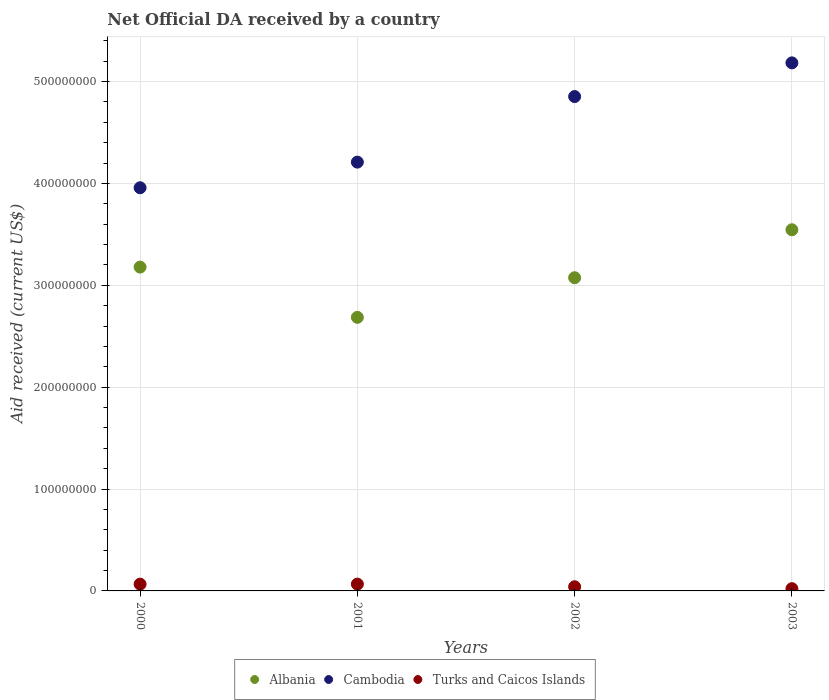How many different coloured dotlines are there?
Make the answer very short. 3. What is the net official development assistance aid received in Turks and Caicos Islands in 2000?
Ensure brevity in your answer.  6.65e+06. Across all years, what is the maximum net official development assistance aid received in Turks and Caicos Islands?
Keep it short and to the point. 6.67e+06. Across all years, what is the minimum net official development assistance aid received in Albania?
Offer a very short reply. 2.69e+08. In which year was the net official development assistance aid received in Cambodia minimum?
Keep it short and to the point. 2000. What is the total net official development assistance aid received in Cambodia in the graph?
Ensure brevity in your answer.  1.82e+09. What is the difference between the net official development assistance aid received in Cambodia in 2000 and that in 2003?
Provide a short and direct response. -1.23e+08. What is the difference between the net official development assistance aid received in Turks and Caicos Islands in 2003 and the net official development assistance aid received in Cambodia in 2001?
Your answer should be compact. -4.19e+08. What is the average net official development assistance aid received in Turks and Caicos Islands per year?
Your answer should be very brief. 4.90e+06. In the year 2001, what is the difference between the net official development assistance aid received in Albania and net official development assistance aid received in Cambodia?
Give a very brief answer. -1.52e+08. In how many years, is the net official development assistance aid received in Turks and Caicos Islands greater than 380000000 US$?
Your answer should be compact. 0. What is the ratio of the net official development assistance aid received in Cambodia in 2001 to that in 2002?
Make the answer very short. 0.87. Is the net official development assistance aid received in Albania in 2000 less than that in 2003?
Offer a terse response. Yes. Is the difference between the net official development assistance aid received in Albania in 2002 and 2003 greater than the difference between the net official development assistance aid received in Cambodia in 2002 and 2003?
Provide a short and direct response. No. What is the difference between the highest and the second highest net official development assistance aid received in Cambodia?
Keep it short and to the point. 3.31e+07. What is the difference between the highest and the lowest net official development assistance aid received in Albania?
Offer a terse response. 8.60e+07. Is it the case that in every year, the sum of the net official development assistance aid received in Turks and Caicos Islands and net official development assistance aid received in Cambodia  is greater than the net official development assistance aid received in Albania?
Provide a succinct answer. Yes. Does the net official development assistance aid received in Albania monotonically increase over the years?
Offer a terse response. No. Is the net official development assistance aid received in Albania strictly greater than the net official development assistance aid received in Turks and Caicos Islands over the years?
Your answer should be compact. Yes. How many dotlines are there?
Your answer should be very brief. 3. How many years are there in the graph?
Provide a succinct answer. 4. Does the graph contain any zero values?
Keep it short and to the point. No. Does the graph contain grids?
Make the answer very short. Yes. How are the legend labels stacked?
Your answer should be very brief. Horizontal. What is the title of the graph?
Make the answer very short. Net Official DA received by a country. Does "Sint Maarten (Dutch part)" appear as one of the legend labels in the graph?
Ensure brevity in your answer.  No. What is the label or title of the X-axis?
Provide a succinct answer. Years. What is the label or title of the Y-axis?
Keep it short and to the point. Aid received (current US$). What is the Aid received (current US$) in Albania in 2000?
Give a very brief answer. 3.18e+08. What is the Aid received (current US$) in Cambodia in 2000?
Provide a succinct answer. 3.96e+08. What is the Aid received (current US$) in Turks and Caicos Islands in 2000?
Ensure brevity in your answer.  6.65e+06. What is the Aid received (current US$) in Albania in 2001?
Provide a short and direct response. 2.69e+08. What is the Aid received (current US$) in Cambodia in 2001?
Your response must be concise. 4.21e+08. What is the Aid received (current US$) in Turks and Caicos Islands in 2001?
Offer a very short reply. 6.67e+06. What is the Aid received (current US$) of Albania in 2002?
Provide a succinct answer. 3.07e+08. What is the Aid received (current US$) of Cambodia in 2002?
Offer a terse response. 4.85e+08. What is the Aid received (current US$) of Turks and Caicos Islands in 2002?
Offer a terse response. 4.10e+06. What is the Aid received (current US$) in Albania in 2003?
Make the answer very short. 3.54e+08. What is the Aid received (current US$) of Cambodia in 2003?
Your answer should be very brief. 5.18e+08. What is the Aid received (current US$) of Turks and Caicos Islands in 2003?
Your answer should be compact. 2.20e+06. Across all years, what is the maximum Aid received (current US$) of Albania?
Ensure brevity in your answer.  3.54e+08. Across all years, what is the maximum Aid received (current US$) in Cambodia?
Ensure brevity in your answer.  5.18e+08. Across all years, what is the maximum Aid received (current US$) in Turks and Caicos Islands?
Offer a very short reply. 6.67e+06. Across all years, what is the minimum Aid received (current US$) of Albania?
Provide a short and direct response. 2.69e+08. Across all years, what is the minimum Aid received (current US$) in Cambodia?
Provide a short and direct response. 3.96e+08. Across all years, what is the minimum Aid received (current US$) of Turks and Caicos Islands?
Your answer should be very brief. 2.20e+06. What is the total Aid received (current US$) of Albania in the graph?
Your response must be concise. 1.25e+09. What is the total Aid received (current US$) in Cambodia in the graph?
Offer a terse response. 1.82e+09. What is the total Aid received (current US$) in Turks and Caicos Islands in the graph?
Your answer should be compact. 1.96e+07. What is the difference between the Aid received (current US$) of Albania in 2000 and that in 2001?
Your answer should be very brief. 4.93e+07. What is the difference between the Aid received (current US$) in Cambodia in 2000 and that in 2001?
Ensure brevity in your answer.  -2.52e+07. What is the difference between the Aid received (current US$) of Turks and Caicos Islands in 2000 and that in 2001?
Your answer should be very brief. -2.00e+04. What is the difference between the Aid received (current US$) in Albania in 2000 and that in 2002?
Your answer should be very brief. 1.04e+07. What is the difference between the Aid received (current US$) of Cambodia in 2000 and that in 2002?
Keep it short and to the point. -8.95e+07. What is the difference between the Aid received (current US$) of Turks and Caicos Islands in 2000 and that in 2002?
Provide a short and direct response. 2.55e+06. What is the difference between the Aid received (current US$) in Albania in 2000 and that in 2003?
Your response must be concise. -3.66e+07. What is the difference between the Aid received (current US$) of Cambodia in 2000 and that in 2003?
Offer a very short reply. -1.23e+08. What is the difference between the Aid received (current US$) of Turks and Caicos Islands in 2000 and that in 2003?
Ensure brevity in your answer.  4.45e+06. What is the difference between the Aid received (current US$) in Albania in 2001 and that in 2002?
Make the answer very short. -3.89e+07. What is the difference between the Aid received (current US$) in Cambodia in 2001 and that in 2002?
Offer a terse response. -6.44e+07. What is the difference between the Aid received (current US$) of Turks and Caicos Islands in 2001 and that in 2002?
Offer a very short reply. 2.57e+06. What is the difference between the Aid received (current US$) in Albania in 2001 and that in 2003?
Offer a terse response. -8.60e+07. What is the difference between the Aid received (current US$) of Cambodia in 2001 and that in 2003?
Your answer should be compact. -9.74e+07. What is the difference between the Aid received (current US$) in Turks and Caicos Islands in 2001 and that in 2003?
Your response must be concise. 4.47e+06. What is the difference between the Aid received (current US$) in Albania in 2002 and that in 2003?
Keep it short and to the point. -4.71e+07. What is the difference between the Aid received (current US$) in Cambodia in 2002 and that in 2003?
Make the answer very short. -3.31e+07. What is the difference between the Aid received (current US$) of Turks and Caicos Islands in 2002 and that in 2003?
Your answer should be very brief. 1.90e+06. What is the difference between the Aid received (current US$) of Albania in 2000 and the Aid received (current US$) of Cambodia in 2001?
Your answer should be compact. -1.03e+08. What is the difference between the Aid received (current US$) of Albania in 2000 and the Aid received (current US$) of Turks and Caicos Islands in 2001?
Ensure brevity in your answer.  3.11e+08. What is the difference between the Aid received (current US$) in Cambodia in 2000 and the Aid received (current US$) in Turks and Caicos Islands in 2001?
Your answer should be compact. 3.89e+08. What is the difference between the Aid received (current US$) of Albania in 2000 and the Aid received (current US$) of Cambodia in 2002?
Your answer should be compact. -1.67e+08. What is the difference between the Aid received (current US$) of Albania in 2000 and the Aid received (current US$) of Turks and Caicos Islands in 2002?
Keep it short and to the point. 3.14e+08. What is the difference between the Aid received (current US$) in Cambodia in 2000 and the Aid received (current US$) in Turks and Caicos Islands in 2002?
Offer a very short reply. 3.92e+08. What is the difference between the Aid received (current US$) of Albania in 2000 and the Aid received (current US$) of Cambodia in 2003?
Your answer should be very brief. -2.00e+08. What is the difference between the Aid received (current US$) in Albania in 2000 and the Aid received (current US$) in Turks and Caicos Islands in 2003?
Provide a succinct answer. 3.16e+08. What is the difference between the Aid received (current US$) of Cambodia in 2000 and the Aid received (current US$) of Turks and Caicos Islands in 2003?
Offer a very short reply. 3.94e+08. What is the difference between the Aid received (current US$) in Albania in 2001 and the Aid received (current US$) in Cambodia in 2002?
Offer a very short reply. -2.17e+08. What is the difference between the Aid received (current US$) in Albania in 2001 and the Aid received (current US$) in Turks and Caicos Islands in 2002?
Your response must be concise. 2.64e+08. What is the difference between the Aid received (current US$) in Cambodia in 2001 and the Aid received (current US$) in Turks and Caicos Islands in 2002?
Offer a terse response. 4.17e+08. What is the difference between the Aid received (current US$) in Albania in 2001 and the Aid received (current US$) in Cambodia in 2003?
Give a very brief answer. -2.50e+08. What is the difference between the Aid received (current US$) of Albania in 2001 and the Aid received (current US$) of Turks and Caicos Islands in 2003?
Give a very brief answer. 2.66e+08. What is the difference between the Aid received (current US$) in Cambodia in 2001 and the Aid received (current US$) in Turks and Caicos Islands in 2003?
Make the answer very short. 4.19e+08. What is the difference between the Aid received (current US$) in Albania in 2002 and the Aid received (current US$) in Cambodia in 2003?
Provide a succinct answer. -2.11e+08. What is the difference between the Aid received (current US$) of Albania in 2002 and the Aid received (current US$) of Turks and Caicos Islands in 2003?
Give a very brief answer. 3.05e+08. What is the difference between the Aid received (current US$) of Cambodia in 2002 and the Aid received (current US$) of Turks and Caicos Islands in 2003?
Keep it short and to the point. 4.83e+08. What is the average Aid received (current US$) of Albania per year?
Give a very brief answer. 3.12e+08. What is the average Aid received (current US$) in Cambodia per year?
Make the answer very short. 4.55e+08. What is the average Aid received (current US$) in Turks and Caicos Islands per year?
Your response must be concise. 4.90e+06. In the year 2000, what is the difference between the Aid received (current US$) of Albania and Aid received (current US$) of Cambodia?
Offer a very short reply. -7.79e+07. In the year 2000, what is the difference between the Aid received (current US$) in Albania and Aid received (current US$) in Turks and Caicos Islands?
Offer a terse response. 3.11e+08. In the year 2000, what is the difference between the Aid received (current US$) of Cambodia and Aid received (current US$) of Turks and Caicos Islands?
Keep it short and to the point. 3.89e+08. In the year 2001, what is the difference between the Aid received (current US$) of Albania and Aid received (current US$) of Cambodia?
Provide a succinct answer. -1.52e+08. In the year 2001, what is the difference between the Aid received (current US$) of Albania and Aid received (current US$) of Turks and Caicos Islands?
Your response must be concise. 2.62e+08. In the year 2001, what is the difference between the Aid received (current US$) in Cambodia and Aid received (current US$) in Turks and Caicos Islands?
Keep it short and to the point. 4.14e+08. In the year 2002, what is the difference between the Aid received (current US$) in Albania and Aid received (current US$) in Cambodia?
Ensure brevity in your answer.  -1.78e+08. In the year 2002, what is the difference between the Aid received (current US$) of Albania and Aid received (current US$) of Turks and Caicos Islands?
Your answer should be compact. 3.03e+08. In the year 2002, what is the difference between the Aid received (current US$) in Cambodia and Aid received (current US$) in Turks and Caicos Islands?
Your response must be concise. 4.81e+08. In the year 2003, what is the difference between the Aid received (current US$) of Albania and Aid received (current US$) of Cambodia?
Ensure brevity in your answer.  -1.64e+08. In the year 2003, what is the difference between the Aid received (current US$) of Albania and Aid received (current US$) of Turks and Caicos Islands?
Keep it short and to the point. 3.52e+08. In the year 2003, what is the difference between the Aid received (current US$) of Cambodia and Aid received (current US$) of Turks and Caicos Islands?
Provide a succinct answer. 5.16e+08. What is the ratio of the Aid received (current US$) in Albania in 2000 to that in 2001?
Your answer should be very brief. 1.18. What is the ratio of the Aid received (current US$) in Cambodia in 2000 to that in 2001?
Offer a very short reply. 0.94. What is the ratio of the Aid received (current US$) of Albania in 2000 to that in 2002?
Offer a very short reply. 1.03. What is the ratio of the Aid received (current US$) in Cambodia in 2000 to that in 2002?
Your answer should be compact. 0.82. What is the ratio of the Aid received (current US$) of Turks and Caicos Islands in 2000 to that in 2002?
Offer a very short reply. 1.62. What is the ratio of the Aid received (current US$) of Albania in 2000 to that in 2003?
Ensure brevity in your answer.  0.9. What is the ratio of the Aid received (current US$) of Cambodia in 2000 to that in 2003?
Offer a terse response. 0.76. What is the ratio of the Aid received (current US$) of Turks and Caicos Islands in 2000 to that in 2003?
Provide a short and direct response. 3.02. What is the ratio of the Aid received (current US$) in Albania in 2001 to that in 2002?
Offer a very short reply. 0.87. What is the ratio of the Aid received (current US$) of Cambodia in 2001 to that in 2002?
Your answer should be compact. 0.87. What is the ratio of the Aid received (current US$) of Turks and Caicos Islands in 2001 to that in 2002?
Offer a terse response. 1.63. What is the ratio of the Aid received (current US$) of Albania in 2001 to that in 2003?
Offer a terse response. 0.76. What is the ratio of the Aid received (current US$) in Cambodia in 2001 to that in 2003?
Your response must be concise. 0.81. What is the ratio of the Aid received (current US$) of Turks and Caicos Islands in 2001 to that in 2003?
Give a very brief answer. 3.03. What is the ratio of the Aid received (current US$) of Albania in 2002 to that in 2003?
Offer a very short reply. 0.87. What is the ratio of the Aid received (current US$) of Cambodia in 2002 to that in 2003?
Ensure brevity in your answer.  0.94. What is the ratio of the Aid received (current US$) of Turks and Caicos Islands in 2002 to that in 2003?
Provide a short and direct response. 1.86. What is the difference between the highest and the second highest Aid received (current US$) in Albania?
Keep it short and to the point. 3.66e+07. What is the difference between the highest and the second highest Aid received (current US$) of Cambodia?
Ensure brevity in your answer.  3.31e+07. What is the difference between the highest and the lowest Aid received (current US$) of Albania?
Provide a short and direct response. 8.60e+07. What is the difference between the highest and the lowest Aid received (current US$) in Cambodia?
Offer a very short reply. 1.23e+08. What is the difference between the highest and the lowest Aid received (current US$) of Turks and Caicos Islands?
Provide a short and direct response. 4.47e+06. 